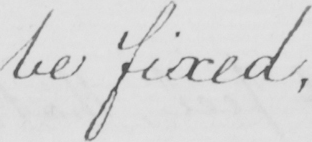What is written in this line of handwriting? be fixed , 